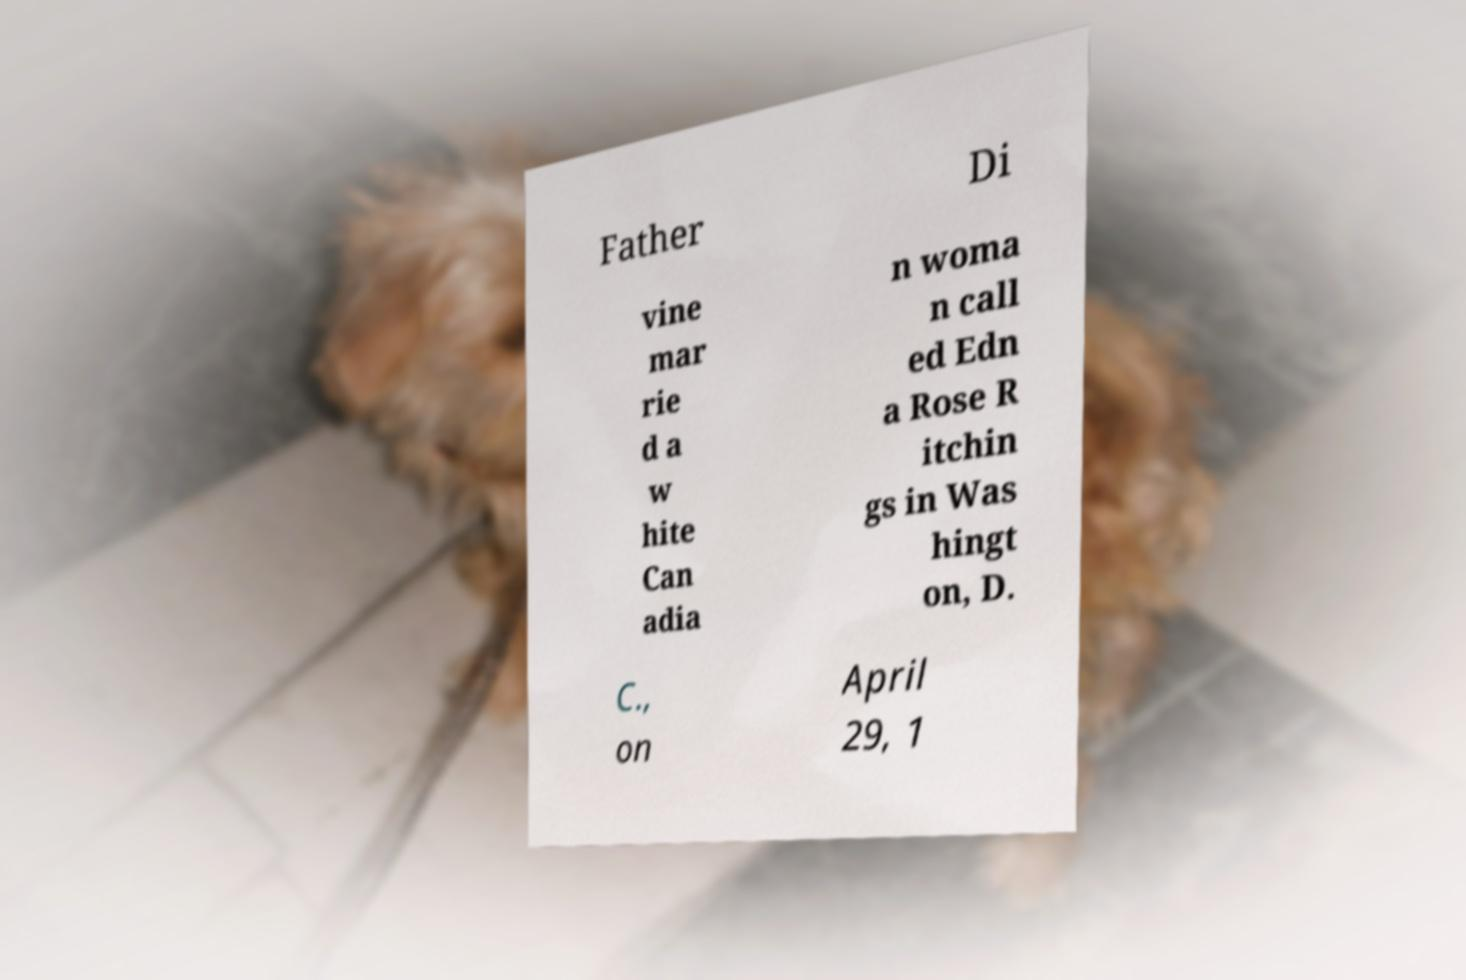Please identify and transcribe the text found in this image. Father Di vine mar rie d a w hite Can adia n woma n call ed Edn a Rose R itchin gs in Was hingt on, D. C., on April 29, 1 